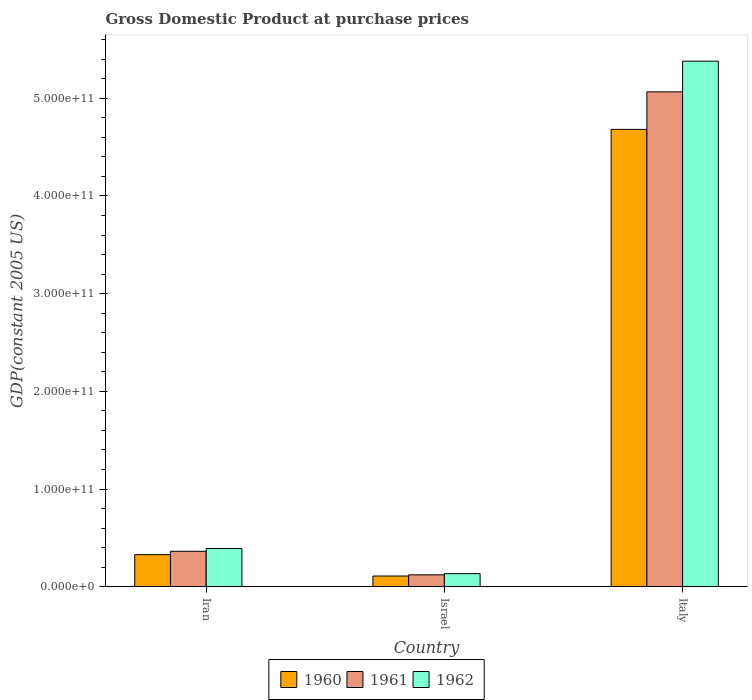How many groups of bars are there?
Keep it short and to the point. 3. What is the label of the 1st group of bars from the left?
Provide a short and direct response. Iran. In how many cases, is the number of bars for a given country not equal to the number of legend labels?
Offer a very short reply. 0. What is the GDP at purchase prices in 1961 in Italy?
Give a very brief answer. 5.07e+11. Across all countries, what is the maximum GDP at purchase prices in 1961?
Your answer should be compact. 5.07e+11. Across all countries, what is the minimum GDP at purchase prices in 1960?
Provide a succinct answer. 1.09e+1. What is the total GDP at purchase prices in 1961 in the graph?
Give a very brief answer. 5.55e+11. What is the difference between the GDP at purchase prices in 1962 in Iran and that in Italy?
Offer a terse response. -4.99e+11. What is the difference between the GDP at purchase prices in 1960 in Italy and the GDP at purchase prices in 1962 in Israel?
Your response must be concise. 4.55e+11. What is the average GDP at purchase prices in 1962 per country?
Give a very brief answer. 1.97e+11. What is the difference between the GDP at purchase prices of/in 1962 and GDP at purchase prices of/in 1960 in Italy?
Keep it short and to the point. 6.99e+1. What is the ratio of the GDP at purchase prices in 1962 in Israel to that in Italy?
Provide a short and direct response. 0.02. Is the GDP at purchase prices in 1961 in Israel less than that in Italy?
Your answer should be compact. Yes. What is the difference between the highest and the second highest GDP at purchase prices in 1961?
Keep it short and to the point. -4.70e+11. What is the difference between the highest and the lowest GDP at purchase prices in 1962?
Offer a very short reply. 5.25e+11. Is the sum of the GDP at purchase prices in 1961 in Israel and Italy greater than the maximum GDP at purchase prices in 1962 across all countries?
Make the answer very short. No. How many countries are there in the graph?
Provide a succinct answer. 3. What is the difference between two consecutive major ticks on the Y-axis?
Ensure brevity in your answer.  1.00e+11. Are the values on the major ticks of Y-axis written in scientific E-notation?
Make the answer very short. Yes. Does the graph contain any zero values?
Your answer should be very brief. No. Does the graph contain grids?
Your answer should be very brief. No. Where does the legend appear in the graph?
Provide a short and direct response. Bottom center. What is the title of the graph?
Provide a short and direct response. Gross Domestic Product at purchase prices. Does "1965" appear as one of the legend labels in the graph?
Your response must be concise. No. What is the label or title of the Y-axis?
Your answer should be compact. GDP(constant 2005 US). What is the GDP(constant 2005 US) of 1960 in Iran?
Provide a short and direct response. 3.28e+1. What is the GDP(constant 2005 US) of 1961 in Iran?
Offer a very short reply. 3.62e+1. What is the GDP(constant 2005 US) of 1962 in Iran?
Ensure brevity in your answer.  3.91e+1. What is the GDP(constant 2005 US) in 1960 in Israel?
Offer a very short reply. 1.09e+1. What is the GDP(constant 2005 US) of 1961 in Israel?
Your answer should be very brief. 1.21e+1. What is the GDP(constant 2005 US) of 1962 in Israel?
Provide a succinct answer. 1.34e+1. What is the GDP(constant 2005 US) of 1960 in Italy?
Your response must be concise. 4.68e+11. What is the GDP(constant 2005 US) in 1961 in Italy?
Offer a very short reply. 5.07e+11. What is the GDP(constant 2005 US) in 1962 in Italy?
Give a very brief answer. 5.38e+11. Across all countries, what is the maximum GDP(constant 2005 US) in 1960?
Offer a very short reply. 4.68e+11. Across all countries, what is the maximum GDP(constant 2005 US) in 1961?
Your response must be concise. 5.07e+11. Across all countries, what is the maximum GDP(constant 2005 US) of 1962?
Keep it short and to the point. 5.38e+11. Across all countries, what is the minimum GDP(constant 2005 US) in 1960?
Provide a succinct answer. 1.09e+1. Across all countries, what is the minimum GDP(constant 2005 US) in 1961?
Keep it short and to the point. 1.21e+1. Across all countries, what is the minimum GDP(constant 2005 US) of 1962?
Ensure brevity in your answer.  1.34e+1. What is the total GDP(constant 2005 US) in 1960 in the graph?
Your answer should be very brief. 5.12e+11. What is the total GDP(constant 2005 US) in 1961 in the graph?
Give a very brief answer. 5.55e+11. What is the total GDP(constant 2005 US) of 1962 in the graph?
Your answer should be very brief. 5.90e+11. What is the difference between the GDP(constant 2005 US) of 1960 in Iran and that in Israel?
Your answer should be compact. 2.19e+1. What is the difference between the GDP(constant 2005 US) in 1961 in Iran and that in Israel?
Make the answer very short. 2.41e+1. What is the difference between the GDP(constant 2005 US) in 1962 in Iran and that in Israel?
Make the answer very short. 2.57e+1. What is the difference between the GDP(constant 2005 US) in 1960 in Iran and that in Italy?
Give a very brief answer. -4.35e+11. What is the difference between the GDP(constant 2005 US) of 1961 in Iran and that in Italy?
Your answer should be very brief. -4.70e+11. What is the difference between the GDP(constant 2005 US) of 1962 in Iran and that in Italy?
Your response must be concise. -4.99e+11. What is the difference between the GDP(constant 2005 US) in 1960 in Israel and that in Italy?
Your answer should be compact. -4.57e+11. What is the difference between the GDP(constant 2005 US) in 1961 in Israel and that in Italy?
Make the answer very short. -4.94e+11. What is the difference between the GDP(constant 2005 US) of 1962 in Israel and that in Italy?
Your response must be concise. -5.25e+11. What is the difference between the GDP(constant 2005 US) of 1960 in Iran and the GDP(constant 2005 US) of 1961 in Israel?
Offer a terse response. 2.07e+1. What is the difference between the GDP(constant 2005 US) of 1960 in Iran and the GDP(constant 2005 US) of 1962 in Israel?
Give a very brief answer. 1.95e+1. What is the difference between the GDP(constant 2005 US) of 1961 in Iran and the GDP(constant 2005 US) of 1962 in Israel?
Ensure brevity in your answer.  2.29e+1. What is the difference between the GDP(constant 2005 US) in 1960 in Iran and the GDP(constant 2005 US) in 1961 in Italy?
Your answer should be compact. -4.74e+11. What is the difference between the GDP(constant 2005 US) of 1960 in Iran and the GDP(constant 2005 US) of 1962 in Italy?
Offer a terse response. -5.05e+11. What is the difference between the GDP(constant 2005 US) of 1961 in Iran and the GDP(constant 2005 US) of 1962 in Italy?
Offer a very short reply. -5.02e+11. What is the difference between the GDP(constant 2005 US) of 1960 in Israel and the GDP(constant 2005 US) of 1961 in Italy?
Make the answer very short. -4.96e+11. What is the difference between the GDP(constant 2005 US) in 1960 in Israel and the GDP(constant 2005 US) in 1962 in Italy?
Keep it short and to the point. -5.27e+11. What is the difference between the GDP(constant 2005 US) in 1961 in Israel and the GDP(constant 2005 US) in 1962 in Italy?
Ensure brevity in your answer.  -5.26e+11. What is the average GDP(constant 2005 US) of 1960 per country?
Offer a very short reply. 1.71e+11. What is the average GDP(constant 2005 US) of 1961 per country?
Your answer should be compact. 1.85e+11. What is the average GDP(constant 2005 US) of 1962 per country?
Make the answer very short. 1.97e+11. What is the difference between the GDP(constant 2005 US) of 1960 and GDP(constant 2005 US) of 1961 in Iran?
Your response must be concise. -3.41e+09. What is the difference between the GDP(constant 2005 US) in 1960 and GDP(constant 2005 US) in 1962 in Iran?
Your answer should be compact. -6.27e+09. What is the difference between the GDP(constant 2005 US) in 1961 and GDP(constant 2005 US) in 1962 in Iran?
Keep it short and to the point. -2.87e+09. What is the difference between the GDP(constant 2005 US) of 1960 and GDP(constant 2005 US) of 1961 in Israel?
Ensure brevity in your answer.  -1.22e+09. What is the difference between the GDP(constant 2005 US) in 1960 and GDP(constant 2005 US) in 1962 in Israel?
Make the answer very short. -2.45e+09. What is the difference between the GDP(constant 2005 US) of 1961 and GDP(constant 2005 US) of 1962 in Israel?
Give a very brief answer. -1.23e+09. What is the difference between the GDP(constant 2005 US) in 1960 and GDP(constant 2005 US) in 1961 in Italy?
Make the answer very short. -3.84e+1. What is the difference between the GDP(constant 2005 US) of 1960 and GDP(constant 2005 US) of 1962 in Italy?
Keep it short and to the point. -6.99e+1. What is the difference between the GDP(constant 2005 US) in 1961 and GDP(constant 2005 US) in 1962 in Italy?
Give a very brief answer. -3.14e+1. What is the ratio of the GDP(constant 2005 US) of 1960 in Iran to that in Israel?
Your response must be concise. 3.01. What is the ratio of the GDP(constant 2005 US) in 1961 in Iran to that in Israel?
Provide a succinct answer. 2.99. What is the ratio of the GDP(constant 2005 US) of 1962 in Iran to that in Israel?
Your answer should be compact. 2.93. What is the ratio of the GDP(constant 2005 US) in 1960 in Iran to that in Italy?
Your answer should be very brief. 0.07. What is the ratio of the GDP(constant 2005 US) of 1961 in Iran to that in Italy?
Your response must be concise. 0.07. What is the ratio of the GDP(constant 2005 US) in 1962 in Iran to that in Italy?
Ensure brevity in your answer.  0.07. What is the ratio of the GDP(constant 2005 US) in 1960 in Israel to that in Italy?
Provide a short and direct response. 0.02. What is the ratio of the GDP(constant 2005 US) in 1961 in Israel to that in Italy?
Offer a terse response. 0.02. What is the ratio of the GDP(constant 2005 US) of 1962 in Israel to that in Italy?
Keep it short and to the point. 0.02. What is the difference between the highest and the second highest GDP(constant 2005 US) in 1960?
Keep it short and to the point. 4.35e+11. What is the difference between the highest and the second highest GDP(constant 2005 US) in 1961?
Keep it short and to the point. 4.70e+11. What is the difference between the highest and the second highest GDP(constant 2005 US) in 1962?
Provide a succinct answer. 4.99e+11. What is the difference between the highest and the lowest GDP(constant 2005 US) of 1960?
Give a very brief answer. 4.57e+11. What is the difference between the highest and the lowest GDP(constant 2005 US) in 1961?
Offer a terse response. 4.94e+11. What is the difference between the highest and the lowest GDP(constant 2005 US) of 1962?
Offer a very short reply. 5.25e+11. 